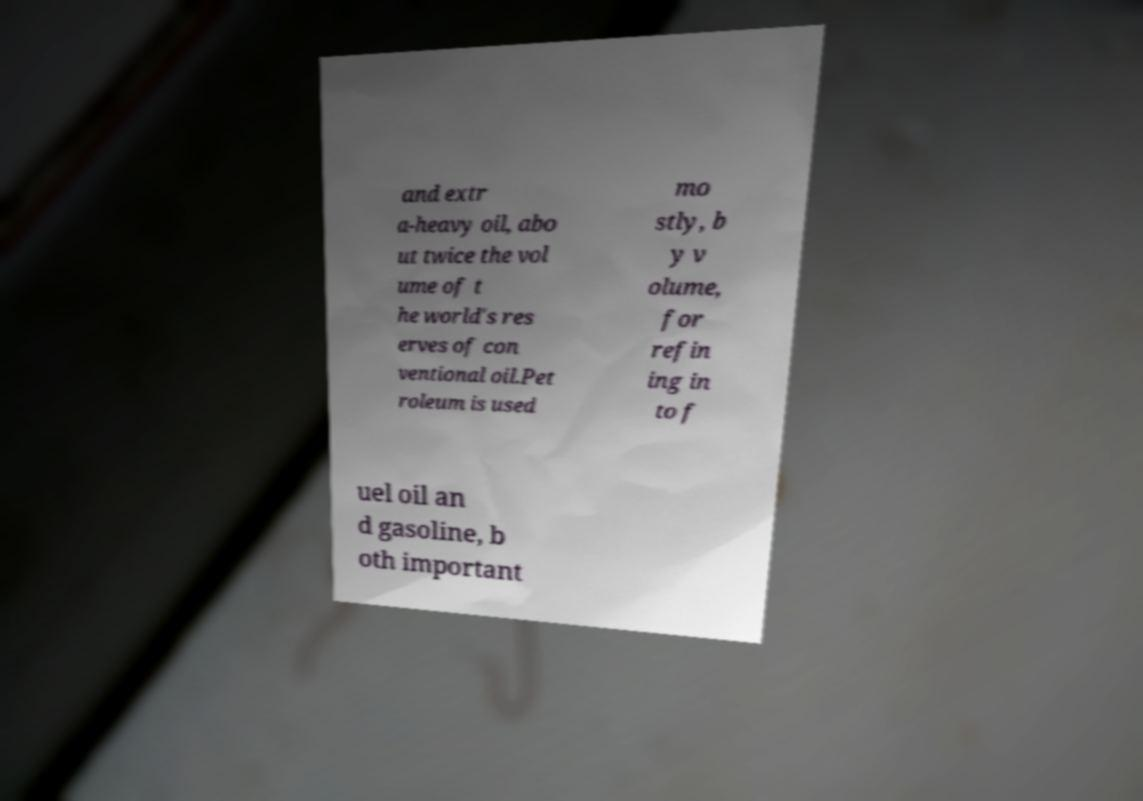Please identify and transcribe the text found in this image. and extr a-heavy oil, abo ut twice the vol ume of t he world's res erves of con ventional oil.Pet roleum is used mo stly, b y v olume, for refin ing in to f uel oil an d gasoline, b oth important 